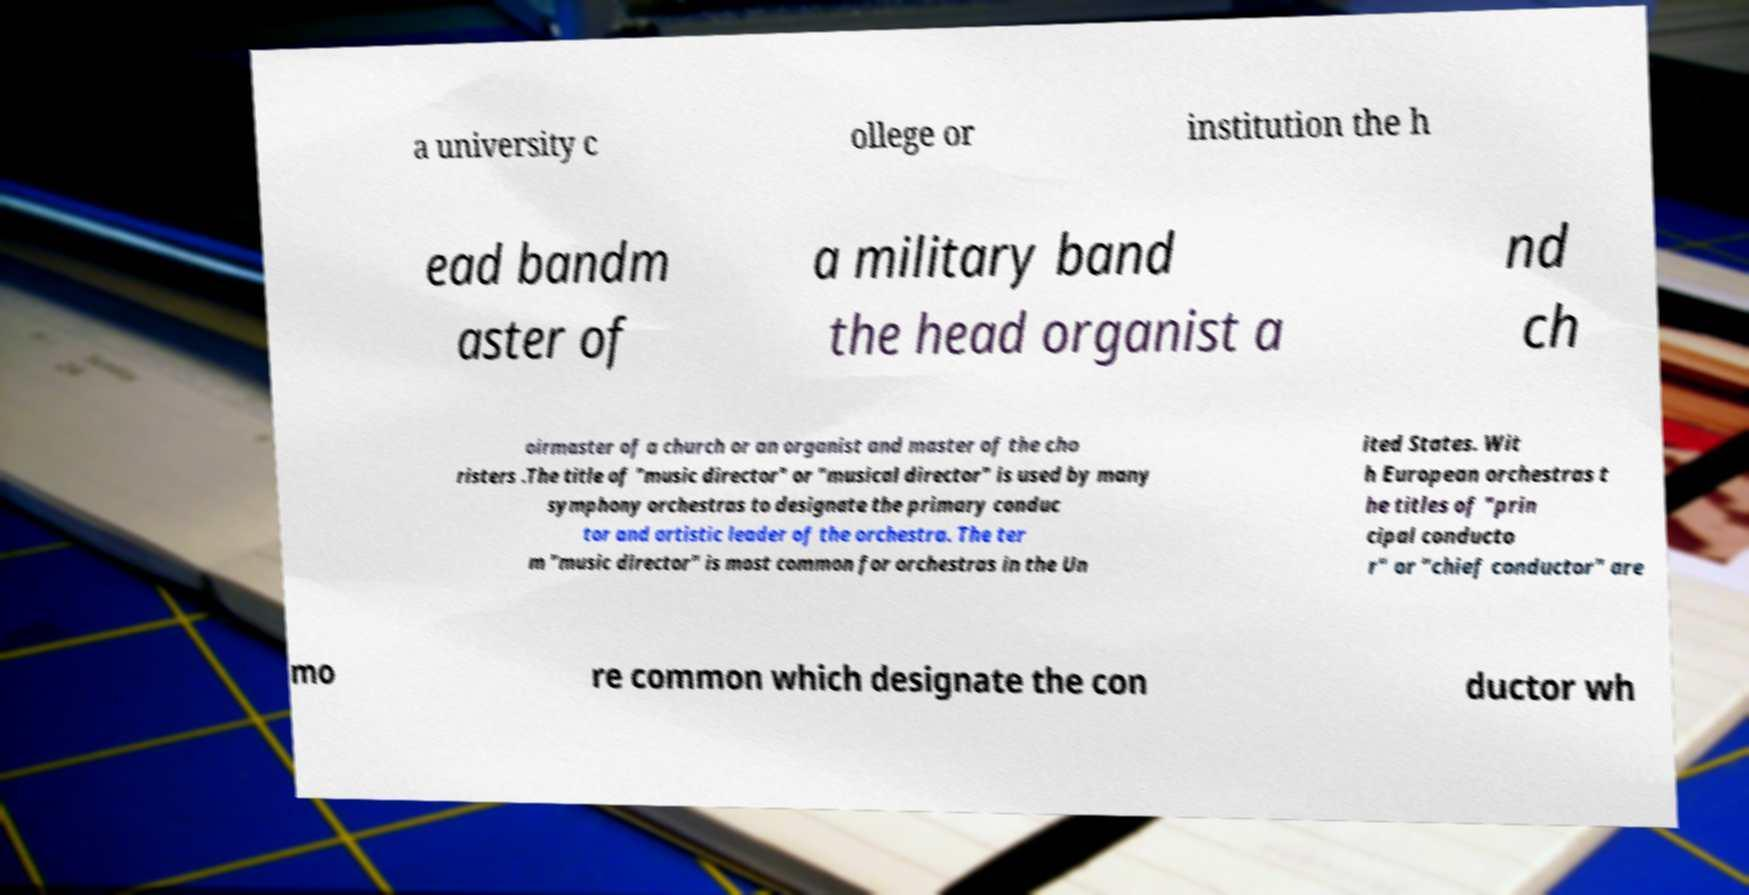Can you accurately transcribe the text from the provided image for me? a university c ollege or institution the h ead bandm aster of a military band the head organist a nd ch oirmaster of a church or an organist and master of the cho risters .The title of "music director" or "musical director" is used by many symphony orchestras to designate the primary conduc tor and artistic leader of the orchestra. The ter m "music director" is most common for orchestras in the Un ited States. Wit h European orchestras t he titles of "prin cipal conducto r" or "chief conductor" are mo re common which designate the con ductor wh 